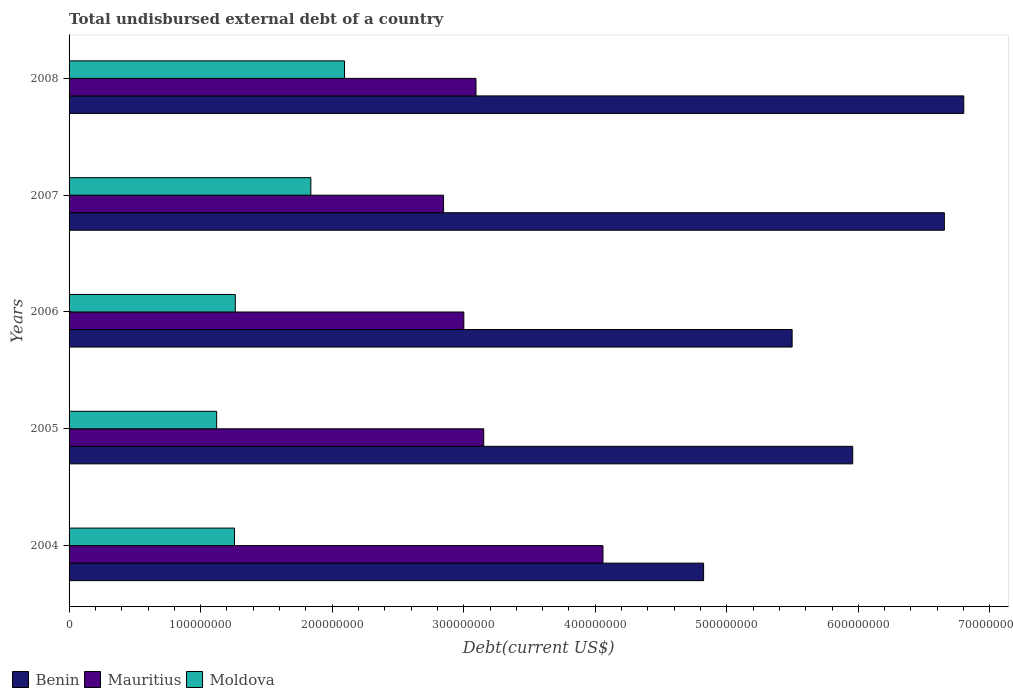Are the number of bars per tick equal to the number of legend labels?
Offer a terse response. Yes. How many bars are there on the 2nd tick from the bottom?
Provide a succinct answer. 3. In how many cases, is the number of bars for a given year not equal to the number of legend labels?
Provide a succinct answer. 0. What is the total undisbursed external debt in Moldova in 2004?
Provide a short and direct response. 1.26e+08. Across all years, what is the maximum total undisbursed external debt in Benin?
Ensure brevity in your answer.  6.80e+08. Across all years, what is the minimum total undisbursed external debt in Mauritius?
Offer a terse response. 2.85e+08. What is the total total undisbursed external debt in Mauritius in the graph?
Keep it short and to the point. 1.62e+09. What is the difference between the total undisbursed external debt in Moldova in 2005 and that in 2007?
Your answer should be very brief. -7.16e+07. What is the difference between the total undisbursed external debt in Benin in 2004 and the total undisbursed external debt in Moldova in 2007?
Provide a short and direct response. 2.99e+08. What is the average total undisbursed external debt in Benin per year?
Provide a short and direct response. 5.95e+08. In the year 2007, what is the difference between the total undisbursed external debt in Benin and total undisbursed external debt in Moldova?
Offer a very short reply. 4.82e+08. In how many years, is the total undisbursed external debt in Moldova greater than 600000000 US$?
Your answer should be very brief. 0. What is the ratio of the total undisbursed external debt in Mauritius in 2006 to that in 2008?
Give a very brief answer. 0.97. Is the difference between the total undisbursed external debt in Benin in 2006 and 2008 greater than the difference between the total undisbursed external debt in Moldova in 2006 and 2008?
Provide a succinct answer. No. What is the difference between the highest and the second highest total undisbursed external debt in Mauritius?
Offer a terse response. 9.07e+07. What is the difference between the highest and the lowest total undisbursed external debt in Mauritius?
Give a very brief answer. 1.21e+08. Is the sum of the total undisbursed external debt in Benin in 2006 and 2008 greater than the maximum total undisbursed external debt in Mauritius across all years?
Keep it short and to the point. Yes. What does the 3rd bar from the top in 2005 represents?
Your answer should be compact. Benin. What does the 2nd bar from the bottom in 2006 represents?
Your answer should be compact. Mauritius. Is it the case that in every year, the sum of the total undisbursed external debt in Moldova and total undisbursed external debt in Benin is greater than the total undisbursed external debt in Mauritius?
Offer a terse response. Yes. Are all the bars in the graph horizontal?
Offer a very short reply. Yes. How many years are there in the graph?
Keep it short and to the point. 5. Are the values on the major ticks of X-axis written in scientific E-notation?
Offer a terse response. No. Does the graph contain grids?
Give a very brief answer. No. How are the legend labels stacked?
Keep it short and to the point. Horizontal. What is the title of the graph?
Your answer should be very brief. Total undisbursed external debt of a country. What is the label or title of the X-axis?
Your response must be concise. Debt(current US$). What is the Debt(current US$) in Benin in 2004?
Make the answer very short. 4.82e+08. What is the Debt(current US$) of Mauritius in 2004?
Make the answer very short. 4.06e+08. What is the Debt(current US$) of Moldova in 2004?
Ensure brevity in your answer.  1.26e+08. What is the Debt(current US$) in Benin in 2005?
Your answer should be compact. 5.96e+08. What is the Debt(current US$) of Mauritius in 2005?
Your answer should be very brief. 3.15e+08. What is the Debt(current US$) in Moldova in 2005?
Make the answer very short. 1.12e+08. What is the Debt(current US$) of Benin in 2006?
Ensure brevity in your answer.  5.50e+08. What is the Debt(current US$) in Mauritius in 2006?
Make the answer very short. 3.00e+08. What is the Debt(current US$) in Moldova in 2006?
Ensure brevity in your answer.  1.26e+08. What is the Debt(current US$) of Benin in 2007?
Offer a terse response. 6.65e+08. What is the Debt(current US$) of Mauritius in 2007?
Keep it short and to the point. 2.85e+08. What is the Debt(current US$) of Moldova in 2007?
Ensure brevity in your answer.  1.84e+08. What is the Debt(current US$) in Benin in 2008?
Provide a short and direct response. 6.80e+08. What is the Debt(current US$) of Mauritius in 2008?
Give a very brief answer. 3.09e+08. What is the Debt(current US$) of Moldova in 2008?
Keep it short and to the point. 2.09e+08. Across all years, what is the maximum Debt(current US$) in Benin?
Provide a short and direct response. 6.80e+08. Across all years, what is the maximum Debt(current US$) of Mauritius?
Offer a terse response. 4.06e+08. Across all years, what is the maximum Debt(current US$) in Moldova?
Provide a succinct answer. 2.09e+08. Across all years, what is the minimum Debt(current US$) of Benin?
Provide a short and direct response. 4.82e+08. Across all years, what is the minimum Debt(current US$) in Mauritius?
Keep it short and to the point. 2.85e+08. Across all years, what is the minimum Debt(current US$) in Moldova?
Make the answer very short. 1.12e+08. What is the total Debt(current US$) in Benin in the graph?
Provide a succinct answer. 2.97e+09. What is the total Debt(current US$) of Mauritius in the graph?
Your response must be concise. 1.62e+09. What is the total Debt(current US$) in Moldova in the graph?
Offer a terse response. 7.58e+08. What is the difference between the Debt(current US$) of Benin in 2004 and that in 2005?
Provide a succinct answer. -1.13e+08. What is the difference between the Debt(current US$) in Mauritius in 2004 and that in 2005?
Your answer should be very brief. 9.07e+07. What is the difference between the Debt(current US$) of Moldova in 2004 and that in 2005?
Provide a short and direct response. 1.36e+07. What is the difference between the Debt(current US$) of Benin in 2004 and that in 2006?
Ensure brevity in your answer.  -6.73e+07. What is the difference between the Debt(current US$) of Mauritius in 2004 and that in 2006?
Make the answer very short. 1.06e+08. What is the difference between the Debt(current US$) in Moldova in 2004 and that in 2006?
Keep it short and to the point. -5.84e+05. What is the difference between the Debt(current US$) in Benin in 2004 and that in 2007?
Your response must be concise. -1.83e+08. What is the difference between the Debt(current US$) in Mauritius in 2004 and that in 2007?
Your answer should be compact. 1.21e+08. What is the difference between the Debt(current US$) in Moldova in 2004 and that in 2007?
Your answer should be very brief. -5.80e+07. What is the difference between the Debt(current US$) in Benin in 2004 and that in 2008?
Provide a short and direct response. -1.98e+08. What is the difference between the Debt(current US$) in Mauritius in 2004 and that in 2008?
Offer a very short reply. 9.65e+07. What is the difference between the Debt(current US$) in Moldova in 2004 and that in 2008?
Your response must be concise. -8.36e+07. What is the difference between the Debt(current US$) of Benin in 2005 and that in 2006?
Keep it short and to the point. 4.61e+07. What is the difference between the Debt(current US$) in Mauritius in 2005 and that in 2006?
Offer a terse response. 1.51e+07. What is the difference between the Debt(current US$) of Moldova in 2005 and that in 2006?
Offer a terse response. -1.42e+07. What is the difference between the Debt(current US$) of Benin in 2005 and that in 2007?
Your answer should be very brief. -6.97e+07. What is the difference between the Debt(current US$) in Mauritius in 2005 and that in 2007?
Your answer should be compact. 3.05e+07. What is the difference between the Debt(current US$) of Moldova in 2005 and that in 2007?
Offer a terse response. -7.16e+07. What is the difference between the Debt(current US$) of Benin in 2005 and that in 2008?
Keep it short and to the point. -8.44e+07. What is the difference between the Debt(current US$) in Mauritius in 2005 and that in 2008?
Provide a short and direct response. 5.88e+06. What is the difference between the Debt(current US$) in Moldova in 2005 and that in 2008?
Provide a short and direct response. -9.72e+07. What is the difference between the Debt(current US$) of Benin in 2006 and that in 2007?
Your answer should be compact. -1.16e+08. What is the difference between the Debt(current US$) in Mauritius in 2006 and that in 2007?
Provide a succinct answer. 1.54e+07. What is the difference between the Debt(current US$) in Moldova in 2006 and that in 2007?
Your response must be concise. -5.74e+07. What is the difference between the Debt(current US$) in Benin in 2006 and that in 2008?
Make the answer very short. -1.30e+08. What is the difference between the Debt(current US$) of Mauritius in 2006 and that in 2008?
Your answer should be compact. -9.25e+06. What is the difference between the Debt(current US$) in Moldova in 2006 and that in 2008?
Make the answer very short. -8.30e+07. What is the difference between the Debt(current US$) of Benin in 2007 and that in 2008?
Offer a very short reply. -1.47e+07. What is the difference between the Debt(current US$) in Mauritius in 2007 and that in 2008?
Keep it short and to the point. -2.47e+07. What is the difference between the Debt(current US$) of Moldova in 2007 and that in 2008?
Your answer should be compact. -2.56e+07. What is the difference between the Debt(current US$) in Benin in 2004 and the Debt(current US$) in Mauritius in 2005?
Offer a terse response. 1.67e+08. What is the difference between the Debt(current US$) in Benin in 2004 and the Debt(current US$) in Moldova in 2005?
Make the answer very short. 3.70e+08. What is the difference between the Debt(current US$) in Mauritius in 2004 and the Debt(current US$) in Moldova in 2005?
Offer a terse response. 2.94e+08. What is the difference between the Debt(current US$) in Benin in 2004 and the Debt(current US$) in Mauritius in 2006?
Your answer should be compact. 1.82e+08. What is the difference between the Debt(current US$) of Benin in 2004 and the Debt(current US$) of Moldova in 2006?
Your answer should be very brief. 3.56e+08. What is the difference between the Debt(current US$) of Mauritius in 2004 and the Debt(current US$) of Moldova in 2006?
Provide a succinct answer. 2.80e+08. What is the difference between the Debt(current US$) in Benin in 2004 and the Debt(current US$) in Mauritius in 2007?
Offer a very short reply. 1.98e+08. What is the difference between the Debt(current US$) in Benin in 2004 and the Debt(current US$) in Moldova in 2007?
Provide a short and direct response. 2.99e+08. What is the difference between the Debt(current US$) in Mauritius in 2004 and the Debt(current US$) in Moldova in 2007?
Offer a terse response. 2.22e+08. What is the difference between the Debt(current US$) in Benin in 2004 and the Debt(current US$) in Mauritius in 2008?
Offer a terse response. 1.73e+08. What is the difference between the Debt(current US$) of Benin in 2004 and the Debt(current US$) of Moldova in 2008?
Provide a succinct answer. 2.73e+08. What is the difference between the Debt(current US$) of Mauritius in 2004 and the Debt(current US$) of Moldova in 2008?
Your response must be concise. 1.96e+08. What is the difference between the Debt(current US$) in Benin in 2005 and the Debt(current US$) in Mauritius in 2006?
Keep it short and to the point. 2.96e+08. What is the difference between the Debt(current US$) of Benin in 2005 and the Debt(current US$) of Moldova in 2006?
Give a very brief answer. 4.69e+08. What is the difference between the Debt(current US$) of Mauritius in 2005 and the Debt(current US$) of Moldova in 2006?
Give a very brief answer. 1.89e+08. What is the difference between the Debt(current US$) of Benin in 2005 and the Debt(current US$) of Mauritius in 2007?
Offer a very short reply. 3.11e+08. What is the difference between the Debt(current US$) of Benin in 2005 and the Debt(current US$) of Moldova in 2007?
Your response must be concise. 4.12e+08. What is the difference between the Debt(current US$) of Mauritius in 2005 and the Debt(current US$) of Moldova in 2007?
Give a very brief answer. 1.31e+08. What is the difference between the Debt(current US$) of Benin in 2005 and the Debt(current US$) of Mauritius in 2008?
Offer a very short reply. 2.86e+08. What is the difference between the Debt(current US$) in Benin in 2005 and the Debt(current US$) in Moldova in 2008?
Give a very brief answer. 3.86e+08. What is the difference between the Debt(current US$) of Mauritius in 2005 and the Debt(current US$) of Moldova in 2008?
Offer a terse response. 1.06e+08. What is the difference between the Debt(current US$) in Benin in 2006 and the Debt(current US$) in Mauritius in 2007?
Provide a short and direct response. 2.65e+08. What is the difference between the Debt(current US$) of Benin in 2006 and the Debt(current US$) of Moldova in 2007?
Your answer should be very brief. 3.66e+08. What is the difference between the Debt(current US$) in Mauritius in 2006 and the Debt(current US$) in Moldova in 2007?
Make the answer very short. 1.16e+08. What is the difference between the Debt(current US$) of Benin in 2006 and the Debt(current US$) of Mauritius in 2008?
Your answer should be very brief. 2.40e+08. What is the difference between the Debt(current US$) in Benin in 2006 and the Debt(current US$) in Moldova in 2008?
Your response must be concise. 3.40e+08. What is the difference between the Debt(current US$) in Mauritius in 2006 and the Debt(current US$) in Moldova in 2008?
Your response must be concise. 9.07e+07. What is the difference between the Debt(current US$) of Benin in 2007 and the Debt(current US$) of Mauritius in 2008?
Your response must be concise. 3.56e+08. What is the difference between the Debt(current US$) of Benin in 2007 and the Debt(current US$) of Moldova in 2008?
Offer a terse response. 4.56e+08. What is the difference between the Debt(current US$) in Mauritius in 2007 and the Debt(current US$) in Moldova in 2008?
Offer a terse response. 7.53e+07. What is the average Debt(current US$) of Benin per year?
Keep it short and to the point. 5.95e+08. What is the average Debt(current US$) in Mauritius per year?
Your answer should be compact. 3.23e+08. What is the average Debt(current US$) of Moldova per year?
Offer a very short reply. 1.52e+08. In the year 2004, what is the difference between the Debt(current US$) in Benin and Debt(current US$) in Mauritius?
Offer a very short reply. 7.65e+07. In the year 2004, what is the difference between the Debt(current US$) in Benin and Debt(current US$) in Moldova?
Your answer should be compact. 3.57e+08. In the year 2004, what is the difference between the Debt(current US$) in Mauritius and Debt(current US$) in Moldova?
Your answer should be very brief. 2.80e+08. In the year 2005, what is the difference between the Debt(current US$) in Benin and Debt(current US$) in Mauritius?
Provide a succinct answer. 2.81e+08. In the year 2005, what is the difference between the Debt(current US$) of Benin and Debt(current US$) of Moldova?
Your answer should be compact. 4.84e+08. In the year 2005, what is the difference between the Debt(current US$) in Mauritius and Debt(current US$) in Moldova?
Your answer should be compact. 2.03e+08. In the year 2006, what is the difference between the Debt(current US$) of Benin and Debt(current US$) of Mauritius?
Ensure brevity in your answer.  2.50e+08. In the year 2006, what is the difference between the Debt(current US$) in Benin and Debt(current US$) in Moldova?
Ensure brevity in your answer.  4.23e+08. In the year 2006, what is the difference between the Debt(current US$) in Mauritius and Debt(current US$) in Moldova?
Your answer should be very brief. 1.74e+08. In the year 2007, what is the difference between the Debt(current US$) in Benin and Debt(current US$) in Mauritius?
Your response must be concise. 3.81e+08. In the year 2007, what is the difference between the Debt(current US$) in Benin and Debt(current US$) in Moldova?
Your response must be concise. 4.82e+08. In the year 2007, what is the difference between the Debt(current US$) of Mauritius and Debt(current US$) of Moldova?
Offer a very short reply. 1.01e+08. In the year 2008, what is the difference between the Debt(current US$) of Benin and Debt(current US$) of Mauritius?
Your answer should be very brief. 3.71e+08. In the year 2008, what is the difference between the Debt(current US$) in Benin and Debt(current US$) in Moldova?
Your response must be concise. 4.71e+08. In the year 2008, what is the difference between the Debt(current US$) in Mauritius and Debt(current US$) in Moldova?
Your response must be concise. 1.00e+08. What is the ratio of the Debt(current US$) of Benin in 2004 to that in 2005?
Provide a short and direct response. 0.81. What is the ratio of the Debt(current US$) in Mauritius in 2004 to that in 2005?
Provide a succinct answer. 1.29. What is the ratio of the Debt(current US$) in Moldova in 2004 to that in 2005?
Ensure brevity in your answer.  1.12. What is the ratio of the Debt(current US$) in Benin in 2004 to that in 2006?
Your answer should be compact. 0.88. What is the ratio of the Debt(current US$) of Mauritius in 2004 to that in 2006?
Your answer should be compact. 1.35. What is the ratio of the Debt(current US$) in Benin in 2004 to that in 2007?
Provide a succinct answer. 0.72. What is the ratio of the Debt(current US$) in Mauritius in 2004 to that in 2007?
Your response must be concise. 1.43. What is the ratio of the Debt(current US$) in Moldova in 2004 to that in 2007?
Make the answer very short. 0.68. What is the ratio of the Debt(current US$) of Benin in 2004 to that in 2008?
Provide a succinct answer. 0.71. What is the ratio of the Debt(current US$) of Mauritius in 2004 to that in 2008?
Provide a short and direct response. 1.31. What is the ratio of the Debt(current US$) in Moldova in 2004 to that in 2008?
Provide a short and direct response. 0.6. What is the ratio of the Debt(current US$) in Benin in 2005 to that in 2006?
Give a very brief answer. 1.08. What is the ratio of the Debt(current US$) in Mauritius in 2005 to that in 2006?
Offer a terse response. 1.05. What is the ratio of the Debt(current US$) of Moldova in 2005 to that in 2006?
Ensure brevity in your answer.  0.89. What is the ratio of the Debt(current US$) in Benin in 2005 to that in 2007?
Ensure brevity in your answer.  0.9. What is the ratio of the Debt(current US$) in Mauritius in 2005 to that in 2007?
Offer a terse response. 1.11. What is the ratio of the Debt(current US$) of Moldova in 2005 to that in 2007?
Offer a very short reply. 0.61. What is the ratio of the Debt(current US$) of Benin in 2005 to that in 2008?
Provide a short and direct response. 0.88. What is the ratio of the Debt(current US$) of Moldova in 2005 to that in 2008?
Your answer should be compact. 0.54. What is the ratio of the Debt(current US$) in Benin in 2006 to that in 2007?
Your response must be concise. 0.83. What is the ratio of the Debt(current US$) in Mauritius in 2006 to that in 2007?
Offer a terse response. 1.05. What is the ratio of the Debt(current US$) of Moldova in 2006 to that in 2007?
Provide a short and direct response. 0.69. What is the ratio of the Debt(current US$) of Benin in 2006 to that in 2008?
Provide a succinct answer. 0.81. What is the ratio of the Debt(current US$) in Mauritius in 2006 to that in 2008?
Offer a very short reply. 0.97. What is the ratio of the Debt(current US$) of Moldova in 2006 to that in 2008?
Keep it short and to the point. 0.6. What is the ratio of the Debt(current US$) of Benin in 2007 to that in 2008?
Your answer should be compact. 0.98. What is the ratio of the Debt(current US$) of Mauritius in 2007 to that in 2008?
Provide a short and direct response. 0.92. What is the ratio of the Debt(current US$) in Moldova in 2007 to that in 2008?
Offer a very short reply. 0.88. What is the difference between the highest and the second highest Debt(current US$) in Benin?
Provide a short and direct response. 1.47e+07. What is the difference between the highest and the second highest Debt(current US$) in Mauritius?
Your answer should be very brief. 9.07e+07. What is the difference between the highest and the second highest Debt(current US$) of Moldova?
Offer a very short reply. 2.56e+07. What is the difference between the highest and the lowest Debt(current US$) of Benin?
Keep it short and to the point. 1.98e+08. What is the difference between the highest and the lowest Debt(current US$) of Mauritius?
Provide a short and direct response. 1.21e+08. What is the difference between the highest and the lowest Debt(current US$) in Moldova?
Provide a succinct answer. 9.72e+07. 